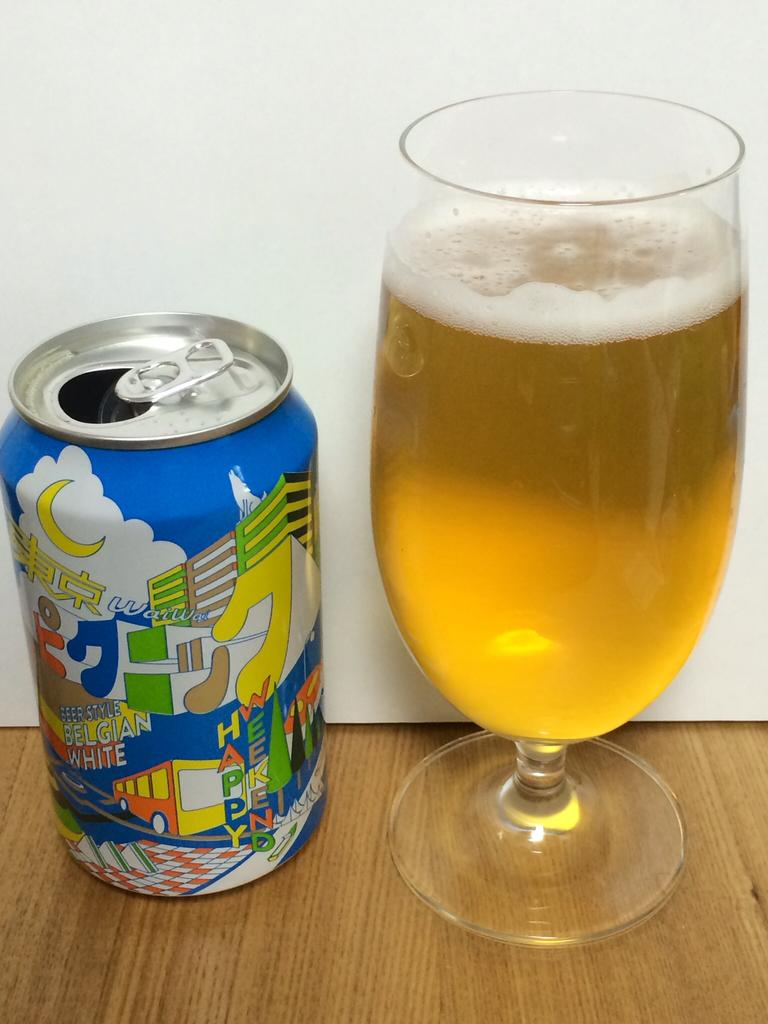<image>
Render a clear and concise summary of the photo. A can of beer style belgian white next to a full glass. 